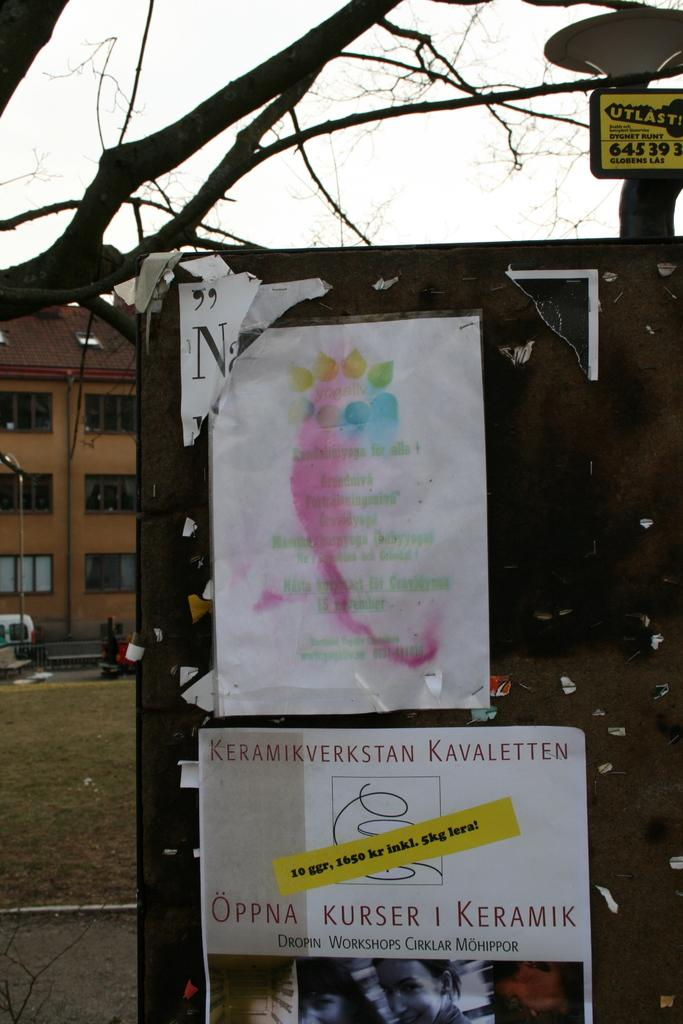What is placed on the board in the image? There are posts placed on a board in the image. What can be seen in the background of the image? There are trees, buildings, and poles in the background of the image. What type of transportation is visible in the image? There is a vehicle visible in the image. What is the opinion of the pen about the zoo in the image? There is no pen or zoo present in the image, so it is not possible to determine any opinions about a zoo. 